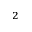<formula> <loc_0><loc_0><loc_500><loc_500>_ { 2 }</formula> 